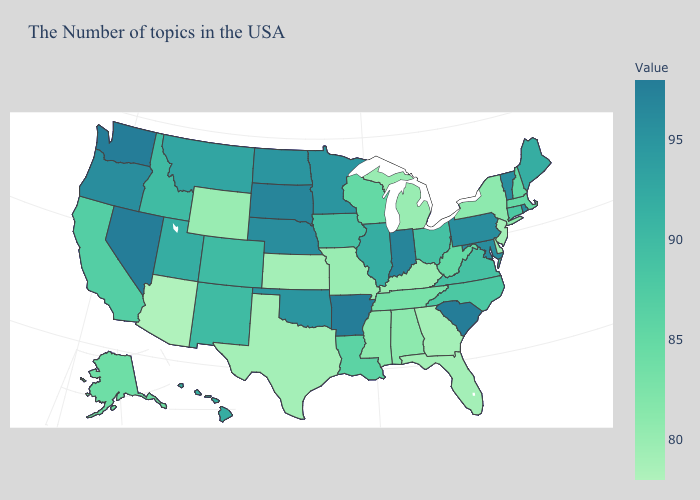Which states have the lowest value in the USA?
Keep it brief. Arizona. Which states have the lowest value in the USA?
Short answer required. Arizona. Does Arizona have the lowest value in the USA?
Be succinct. Yes. Among the states that border Tennessee , does Virginia have the lowest value?
Be succinct. No. Which states have the lowest value in the MidWest?
Concise answer only. Kansas. Does Montana have a lower value than Washington?
Keep it brief. Yes. Does the map have missing data?
Concise answer only. No. Does the map have missing data?
Quick response, please. No. 